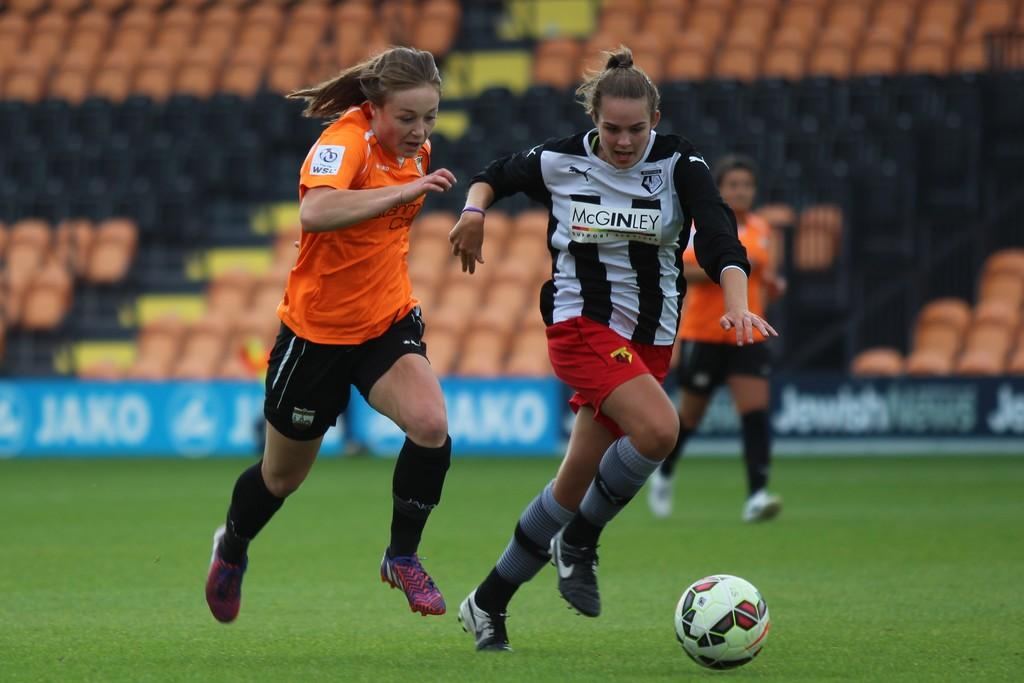<image>
Describe the image concisely. two girls playing soccer on a field sponsoed by jaxo 